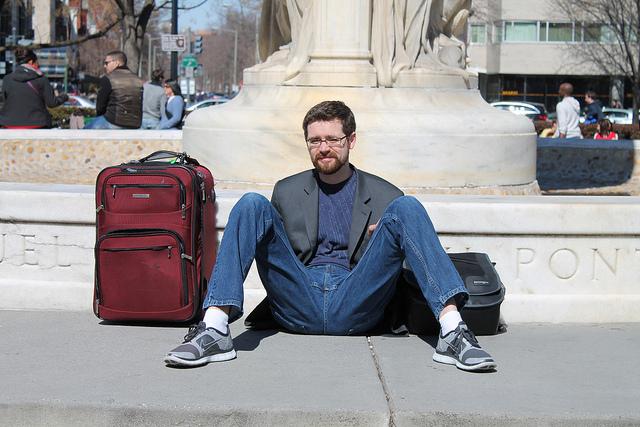What is this man likely doing?
Concise answer only. Waiting. Does the cement hurt?
Be succinct. Yes. IS this man sitting appropriately?
Concise answer only. No. 